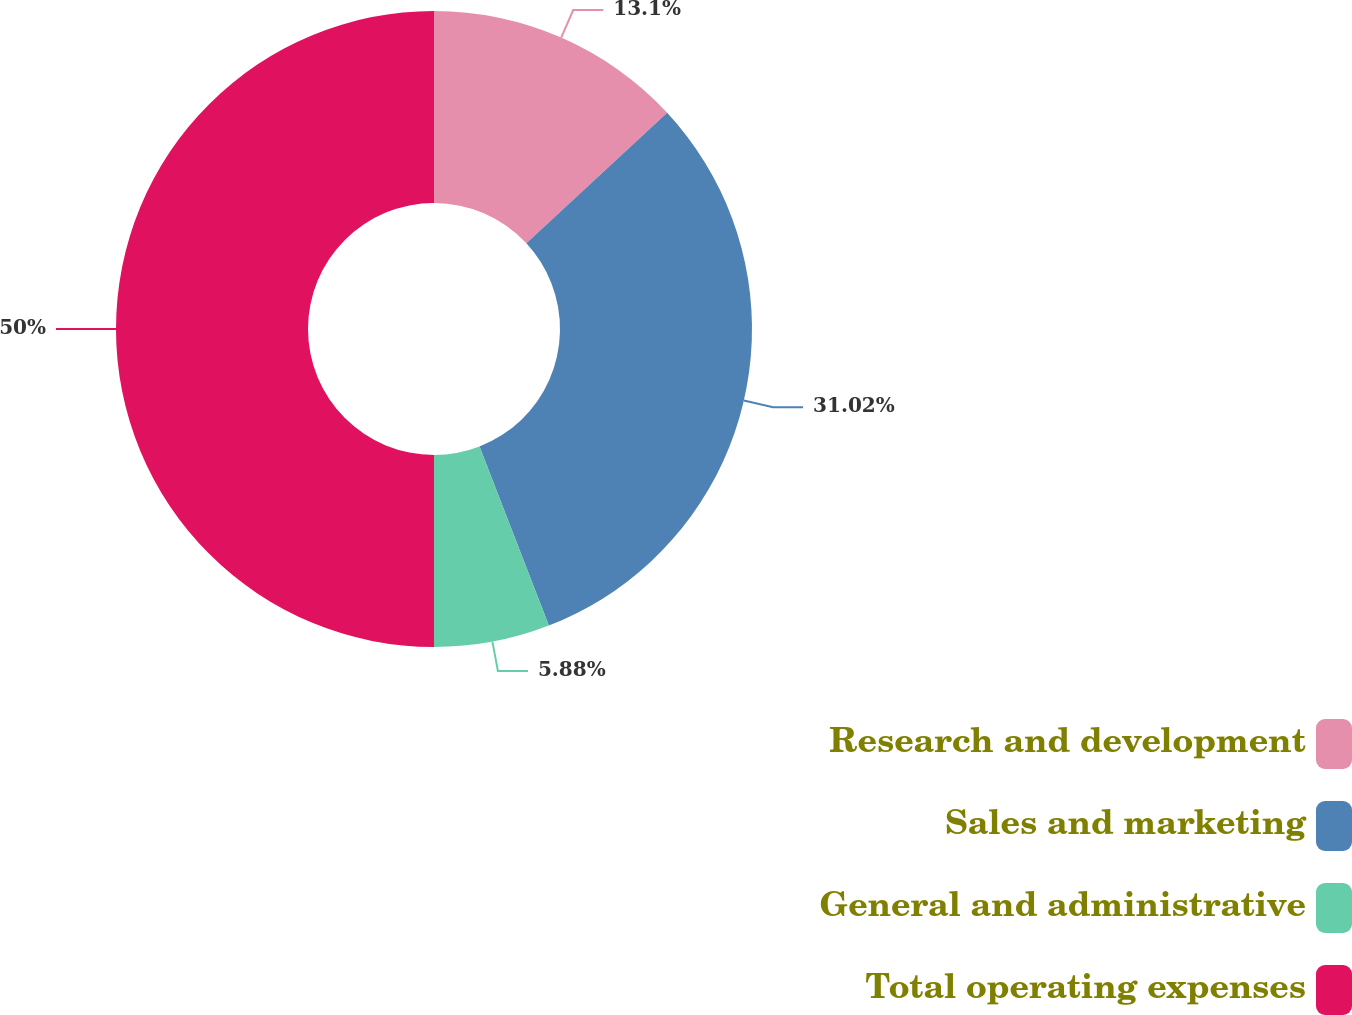Convert chart. <chart><loc_0><loc_0><loc_500><loc_500><pie_chart><fcel>Research and development<fcel>Sales and marketing<fcel>General and administrative<fcel>Total operating expenses<nl><fcel>13.1%<fcel>31.02%<fcel>5.88%<fcel>50.0%<nl></chart> 